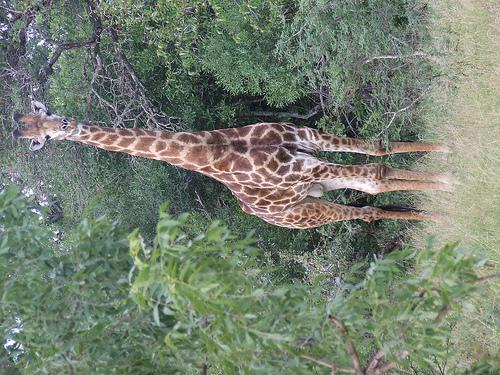Question: how many giraffe are there?
Choices:
A. One.
B. Two.
C. Three.
D. Four.
Answer with the letter. Answer: A Question: why is it so bright?
Choices:
A. Sunny.
B. The sun is at high noon.
C. No clouds in the sky.
D. It is day time.
Answer with the letter. Answer: A Question: where was the photo taken?
Choices:
A. In the woods.
B. In a forest.
C. In the jungle.
D. In the wilderness.
Answer with the letter. Answer: B Question: what animal is there?
Choices:
A. Gorilla.
B. Giraffe.
C. Lion.
D. Tiger.
Answer with the letter. Answer: B Question: where is the giraffe?
Choices:
A. The wetlands.
B. The grass.
C. The water hole.
D. The desert.
Answer with the letter. Answer: B 